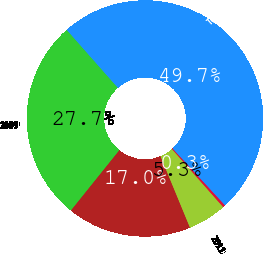Convert chart. <chart><loc_0><loc_0><loc_500><loc_500><pie_chart><fcel>2009<fcel>2010<fcel>2011<fcel>2012<fcel>Total expected amortization<nl><fcel>27.72%<fcel>17.0%<fcel>5.28%<fcel>0.35%<fcel>49.65%<nl></chart> 